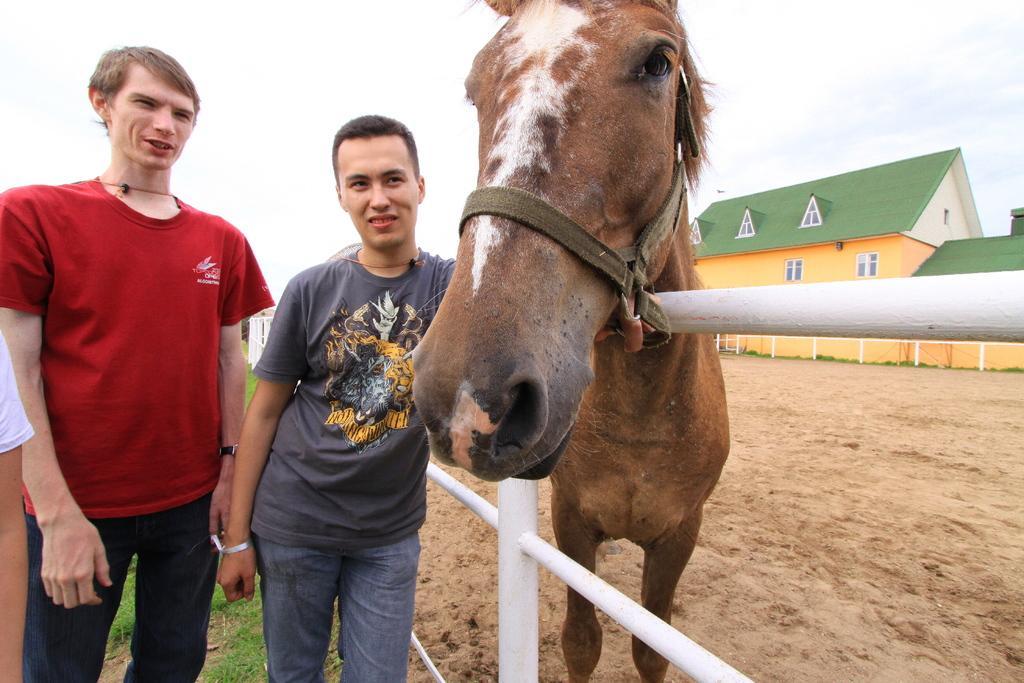Describe this image in one or two sentences. In this picture, we see two men standing. Beside them, we see a horse and an iron railing. Man in grey t-shirt is holding the rope of the horse and behind that, we see a building in yellow and green color. On the right bottom of the picture, we see sand and beside that, we see grass and on the top of the picture, we see sky. 